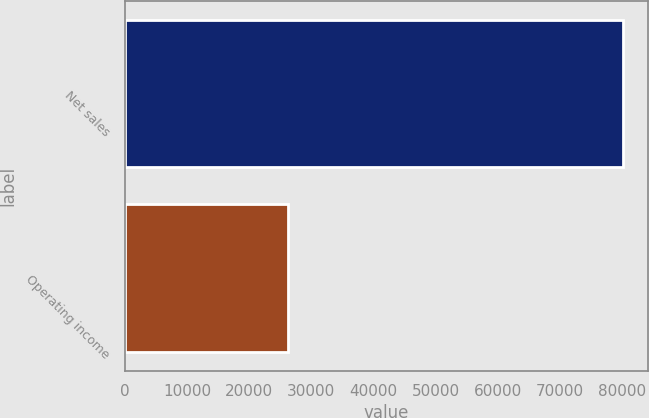<chart> <loc_0><loc_0><loc_500><loc_500><bar_chart><fcel>Net sales<fcel>Operating income<nl><fcel>80095<fcel>26158<nl></chart> 